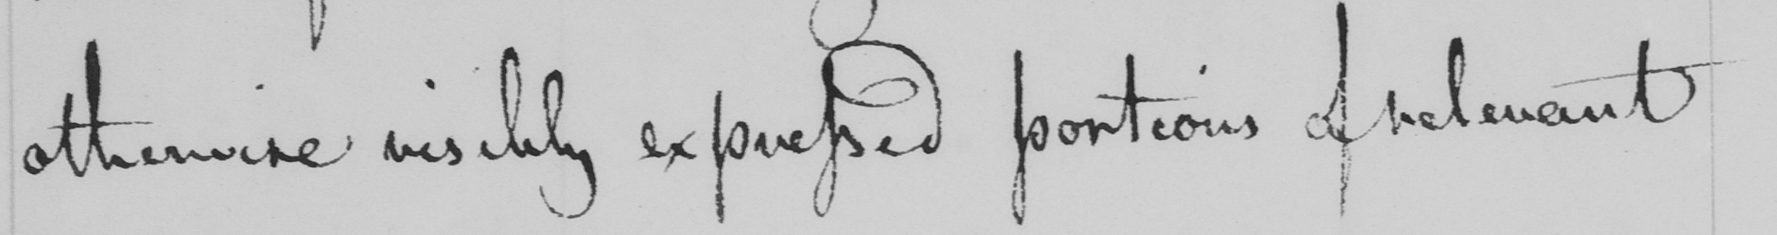Transcribe the text shown in this historical manuscript line. otherwise visibly expressed portions of relevant 